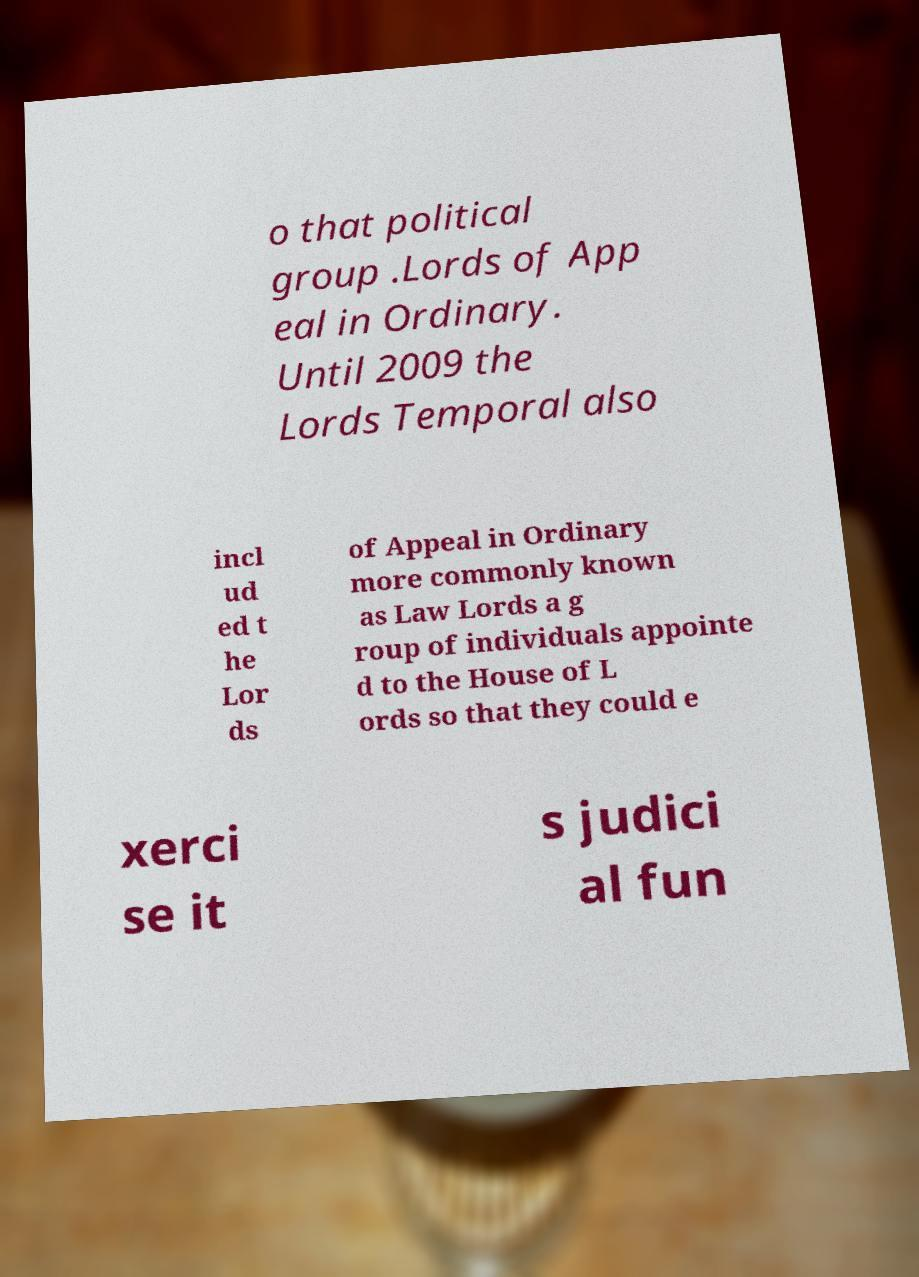Can you read and provide the text displayed in the image?This photo seems to have some interesting text. Can you extract and type it out for me? o that political group .Lords of App eal in Ordinary. Until 2009 the Lords Temporal also incl ud ed t he Lor ds of Appeal in Ordinary more commonly known as Law Lords a g roup of individuals appointe d to the House of L ords so that they could e xerci se it s judici al fun 